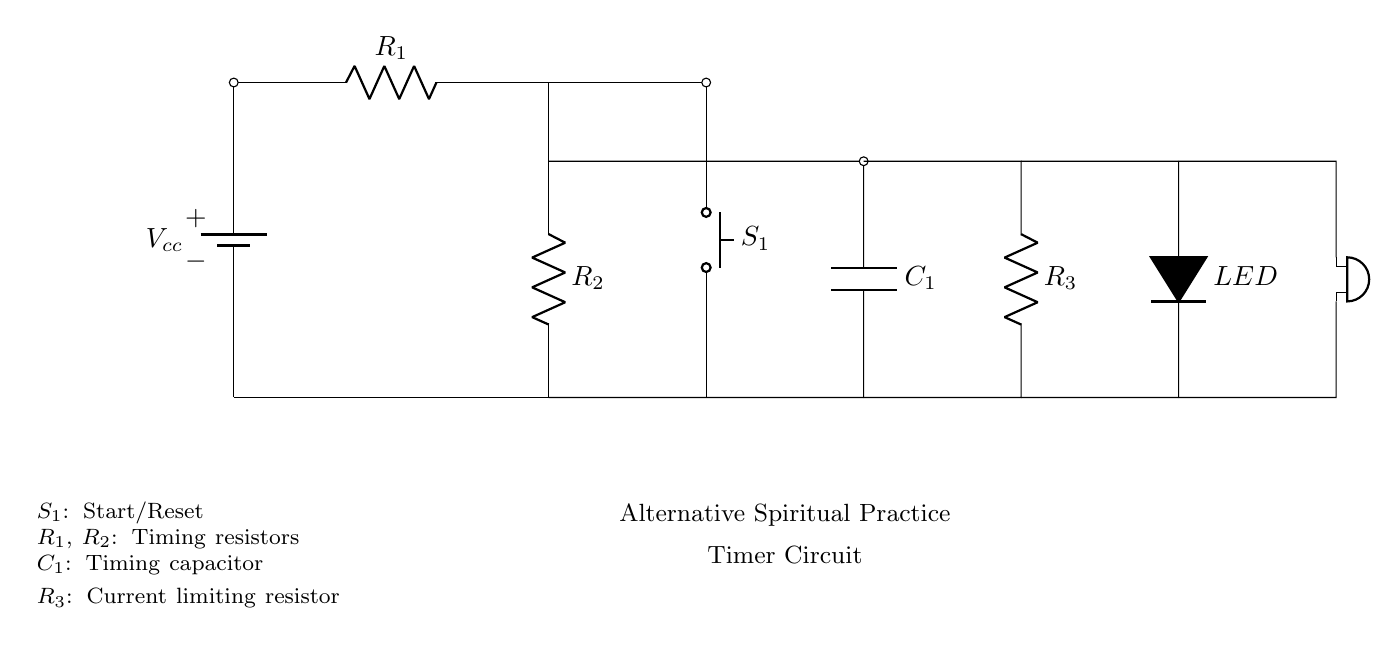What is the purpose of component S1? S1 is a push button used for starting and resetting the timer in the circuit. When pressed, it allows the timing process to begin or reset the current timing cycle.
Answer: Start/Reset What is the function of the LED in the circuit? The LED acts as an indicator that shows when the timer is active or triggered. It lights up to signify the operation of the timer function.
Answer: Indicator How many resistors are present in the circuit? There are three resistors (R1, R2, R3) in the circuit diagram, as indicated by their labels along the connections.
Answer: Three What role does the capacitor C1 play in this timer circuit? C1 is used as a timing capacitor that, in conjunction with resistors, determines the intervals for the timer's operation. It stores electrical energy temporarily to control timing.
Answer: Timing capacitor Which component produces sound in the circuit? The buzzer is responsible for producing sound, which alerts the user at the end of each timing interval set by the circuit.
Answer: Buzzer What type of circuit is shown? This is a simple timer circuit primarily designed for low power applications, utilizing components suited for managing intervals in meditation or prayer practices.
Answer: Timer circuit 